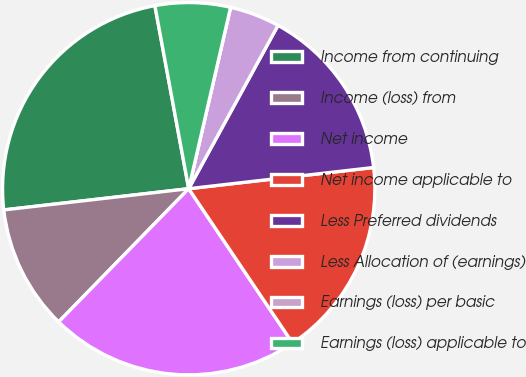Convert chart to OTSL. <chart><loc_0><loc_0><loc_500><loc_500><pie_chart><fcel>Income from continuing<fcel>Income (loss) from<fcel>Net income<fcel>Net income applicable to<fcel>Less Preferred dividends<fcel>Less Allocation of (earnings)<fcel>Earnings (loss) per basic<fcel>Earnings (loss) applicable to<nl><fcel>23.91%<fcel>10.87%<fcel>21.74%<fcel>17.39%<fcel>15.22%<fcel>4.35%<fcel>0.0%<fcel>6.52%<nl></chart> 